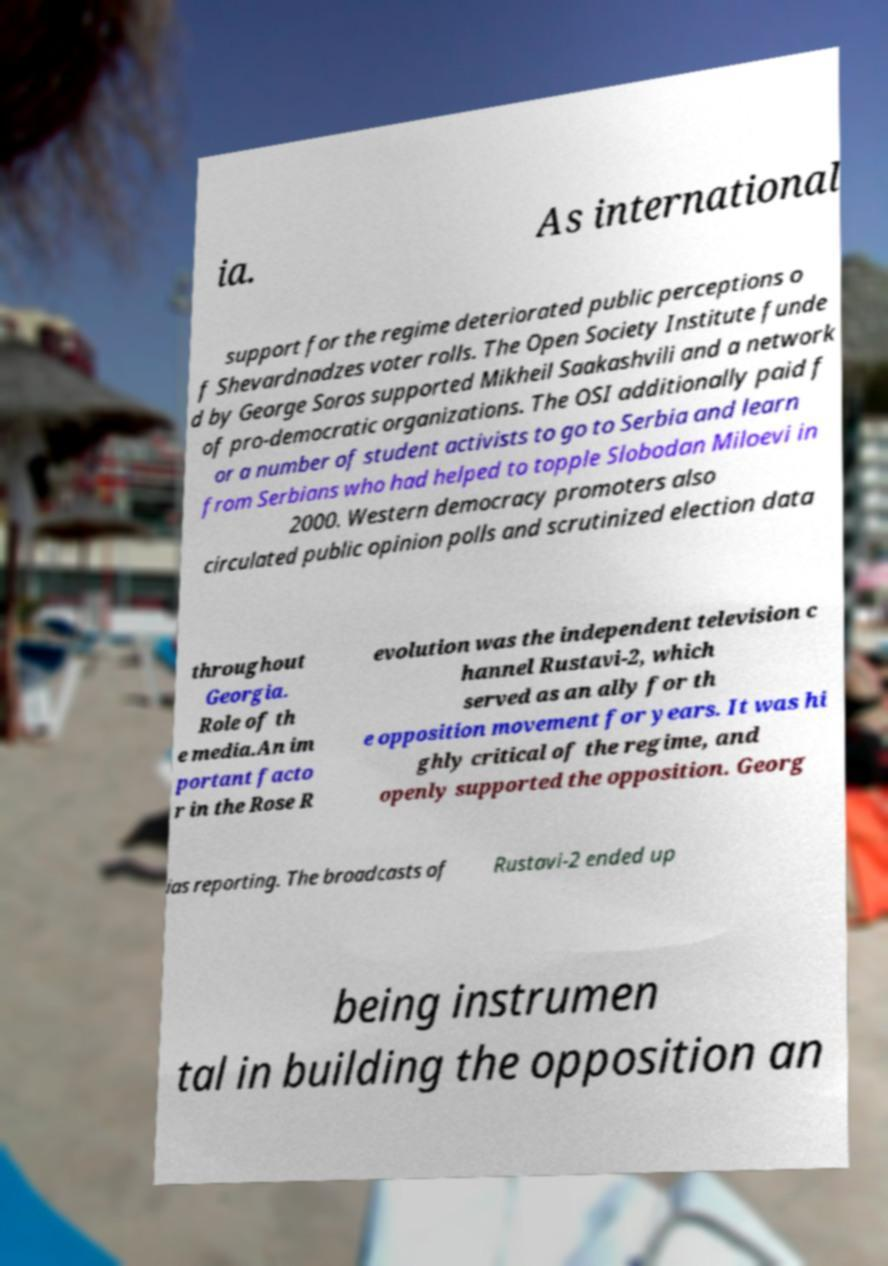Can you accurately transcribe the text from the provided image for me? ia. As international support for the regime deteriorated public perceptions o f Shevardnadzes voter rolls. The Open Society Institute funde d by George Soros supported Mikheil Saakashvili and a network of pro-democratic organizations. The OSI additionally paid f or a number of student activists to go to Serbia and learn from Serbians who had helped to topple Slobodan Miloevi in 2000. Western democracy promoters also circulated public opinion polls and scrutinized election data throughout Georgia. Role of th e media.An im portant facto r in the Rose R evolution was the independent television c hannel Rustavi-2, which served as an ally for th e opposition movement for years. It was hi ghly critical of the regime, and openly supported the opposition. Georg ias reporting. The broadcasts of Rustavi-2 ended up being instrumen tal in building the opposition an 